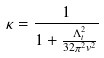<formula> <loc_0><loc_0><loc_500><loc_500>\kappa = \frac { 1 } { 1 + \frac { \Lambda _ { t } ^ { 2 } } { 3 2 \pi ^ { 2 } v ^ { 2 } } }</formula> 